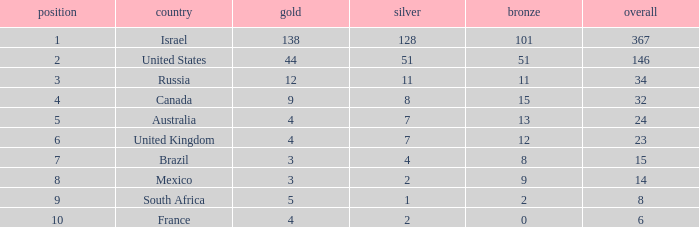What is the gold medal count for the country with a total greater than 32 and more than 128 silvers? None. Give me the full table as a dictionary. {'header': ['position', 'country', 'gold', 'silver', 'bronze', 'overall'], 'rows': [['1', 'Israel', '138', '128', '101', '367'], ['2', 'United States', '44', '51', '51', '146'], ['3', 'Russia', '12', '11', '11', '34'], ['4', 'Canada', '9', '8', '15', '32'], ['5', 'Australia', '4', '7', '13', '24'], ['6', 'United Kingdom', '4', '7', '12', '23'], ['7', 'Brazil', '3', '4', '8', '15'], ['8', 'Mexico', '3', '2', '9', '14'], ['9', 'South Africa', '5', '1', '2', '8'], ['10', 'France', '4', '2', '0', '6']]} 